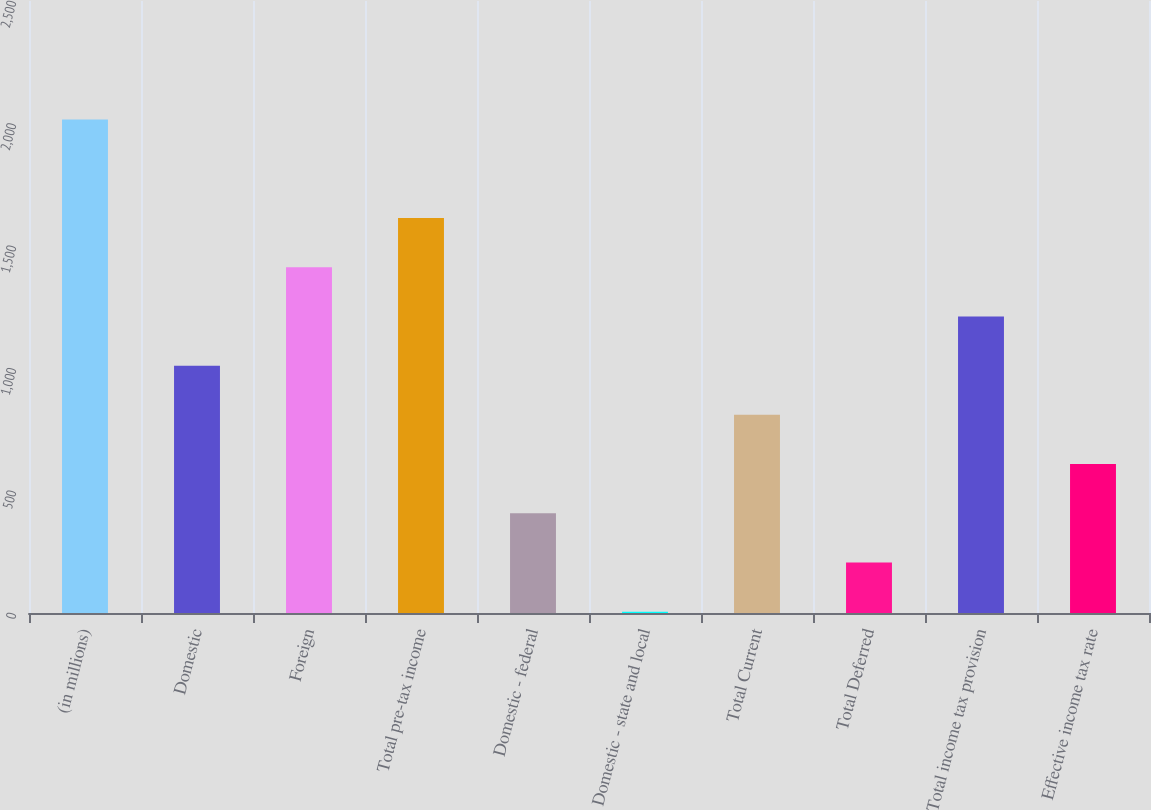Convert chart to OTSL. <chart><loc_0><loc_0><loc_500><loc_500><bar_chart><fcel>(in millions)<fcel>Domestic<fcel>Foreign<fcel>Total pre-tax income<fcel>Domestic - federal<fcel>Domestic - state and local<fcel>Total Current<fcel>Total Deferred<fcel>Total income tax provision<fcel>Effective income tax rate<nl><fcel>2016<fcel>1010.5<fcel>1412.7<fcel>1613.8<fcel>407.2<fcel>5<fcel>809.4<fcel>206.1<fcel>1211.6<fcel>608.3<nl></chart> 